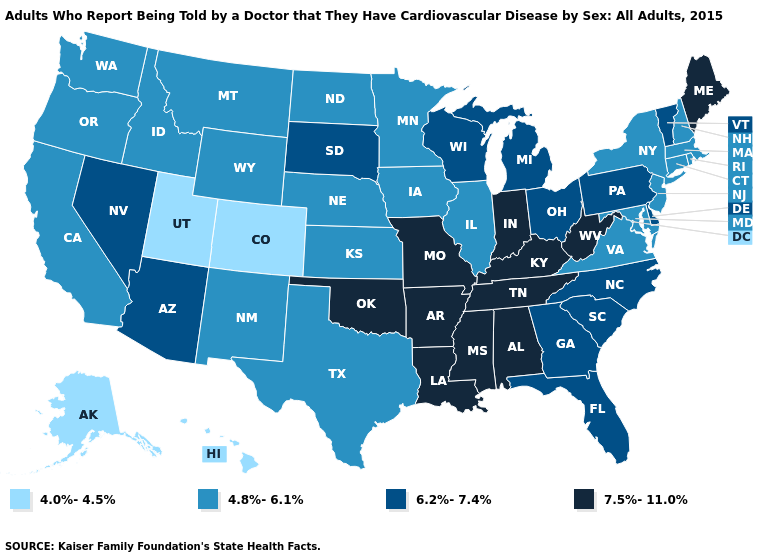Does Indiana have the highest value in the MidWest?
Quick response, please. Yes. How many symbols are there in the legend?
Answer briefly. 4. Which states hav the highest value in the West?
Write a very short answer. Arizona, Nevada. Among the states that border Idaho , does Nevada have the highest value?
Be succinct. Yes. Which states have the lowest value in the Northeast?
Short answer required. Connecticut, Massachusetts, New Hampshire, New Jersey, New York, Rhode Island. How many symbols are there in the legend?
Keep it brief. 4. Among the states that border New Hampshire , does Maine have the highest value?
Give a very brief answer. Yes. Does Massachusetts have a lower value than Arkansas?
Short answer required. Yes. What is the value of Wyoming?
Quick response, please. 4.8%-6.1%. Which states have the lowest value in the West?
Give a very brief answer. Alaska, Colorado, Hawaii, Utah. Does Alaska have the lowest value in the USA?
Be succinct. Yes. How many symbols are there in the legend?
Be succinct. 4. Is the legend a continuous bar?
Answer briefly. No. Name the states that have a value in the range 7.5%-11.0%?
Answer briefly. Alabama, Arkansas, Indiana, Kentucky, Louisiana, Maine, Mississippi, Missouri, Oklahoma, Tennessee, West Virginia. Which states have the lowest value in the Northeast?
Give a very brief answer. Connecticut, Massachusetts, New Hampshire, New Jersey, New York, Rhode Island. 